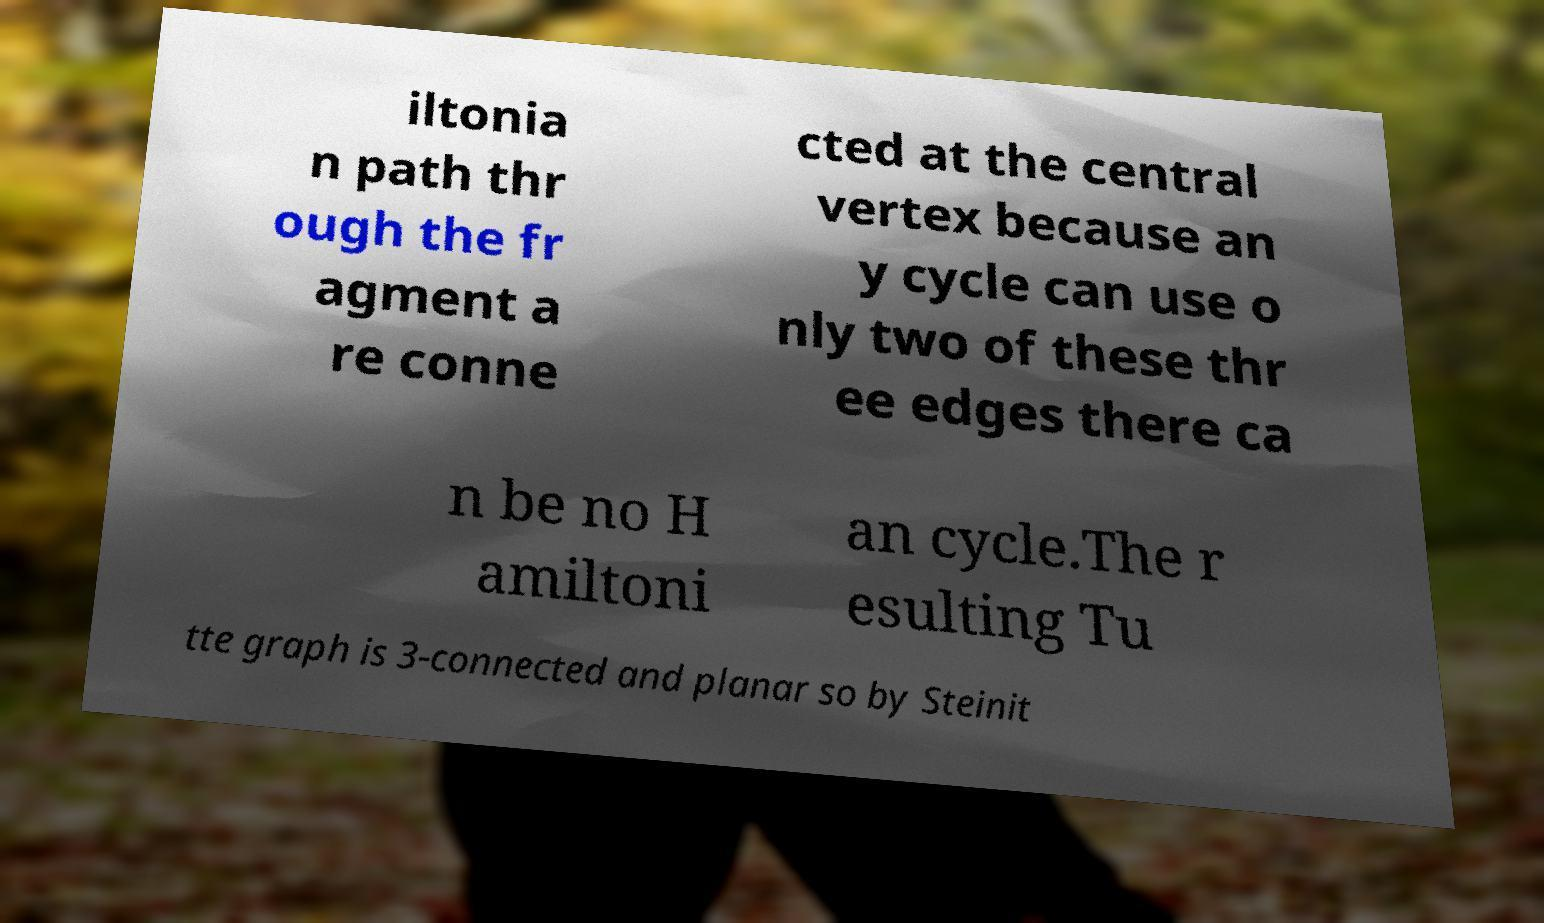For documentation purposes, I need the text within this image transcribed. Could you provide that? iltonia n path thr ough the fr agment a re conne cted at the central vertex because an y cycle can use o nly two of these thr ee edges there ca n be no H amiltoni an cycle.The r esulting Tu tte graph is 3-connected and planar so by Steinit 